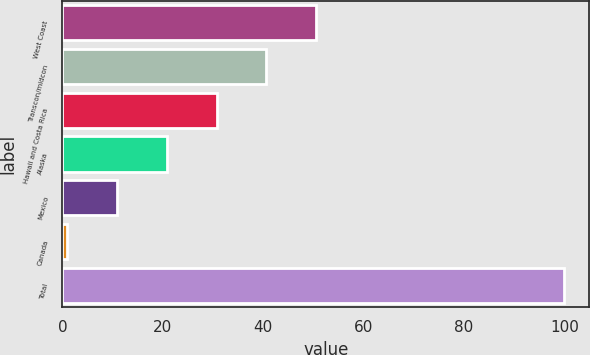<chart> <loc_0><loc_0><loc_500><loc_500><bar_chart><fcel>West Coast<fcel>Transcon/midcon<fcel>Hawaii and Costa Rica<fcel>Alaska<fcel>Mexico<fcel>Canada<fcel>Total<nl><fcel>50.5<fcel>40.6<fcel>30.7<fcel>20.8<fcel>10.9<fcel>1<fcel>100<nl></chart> 